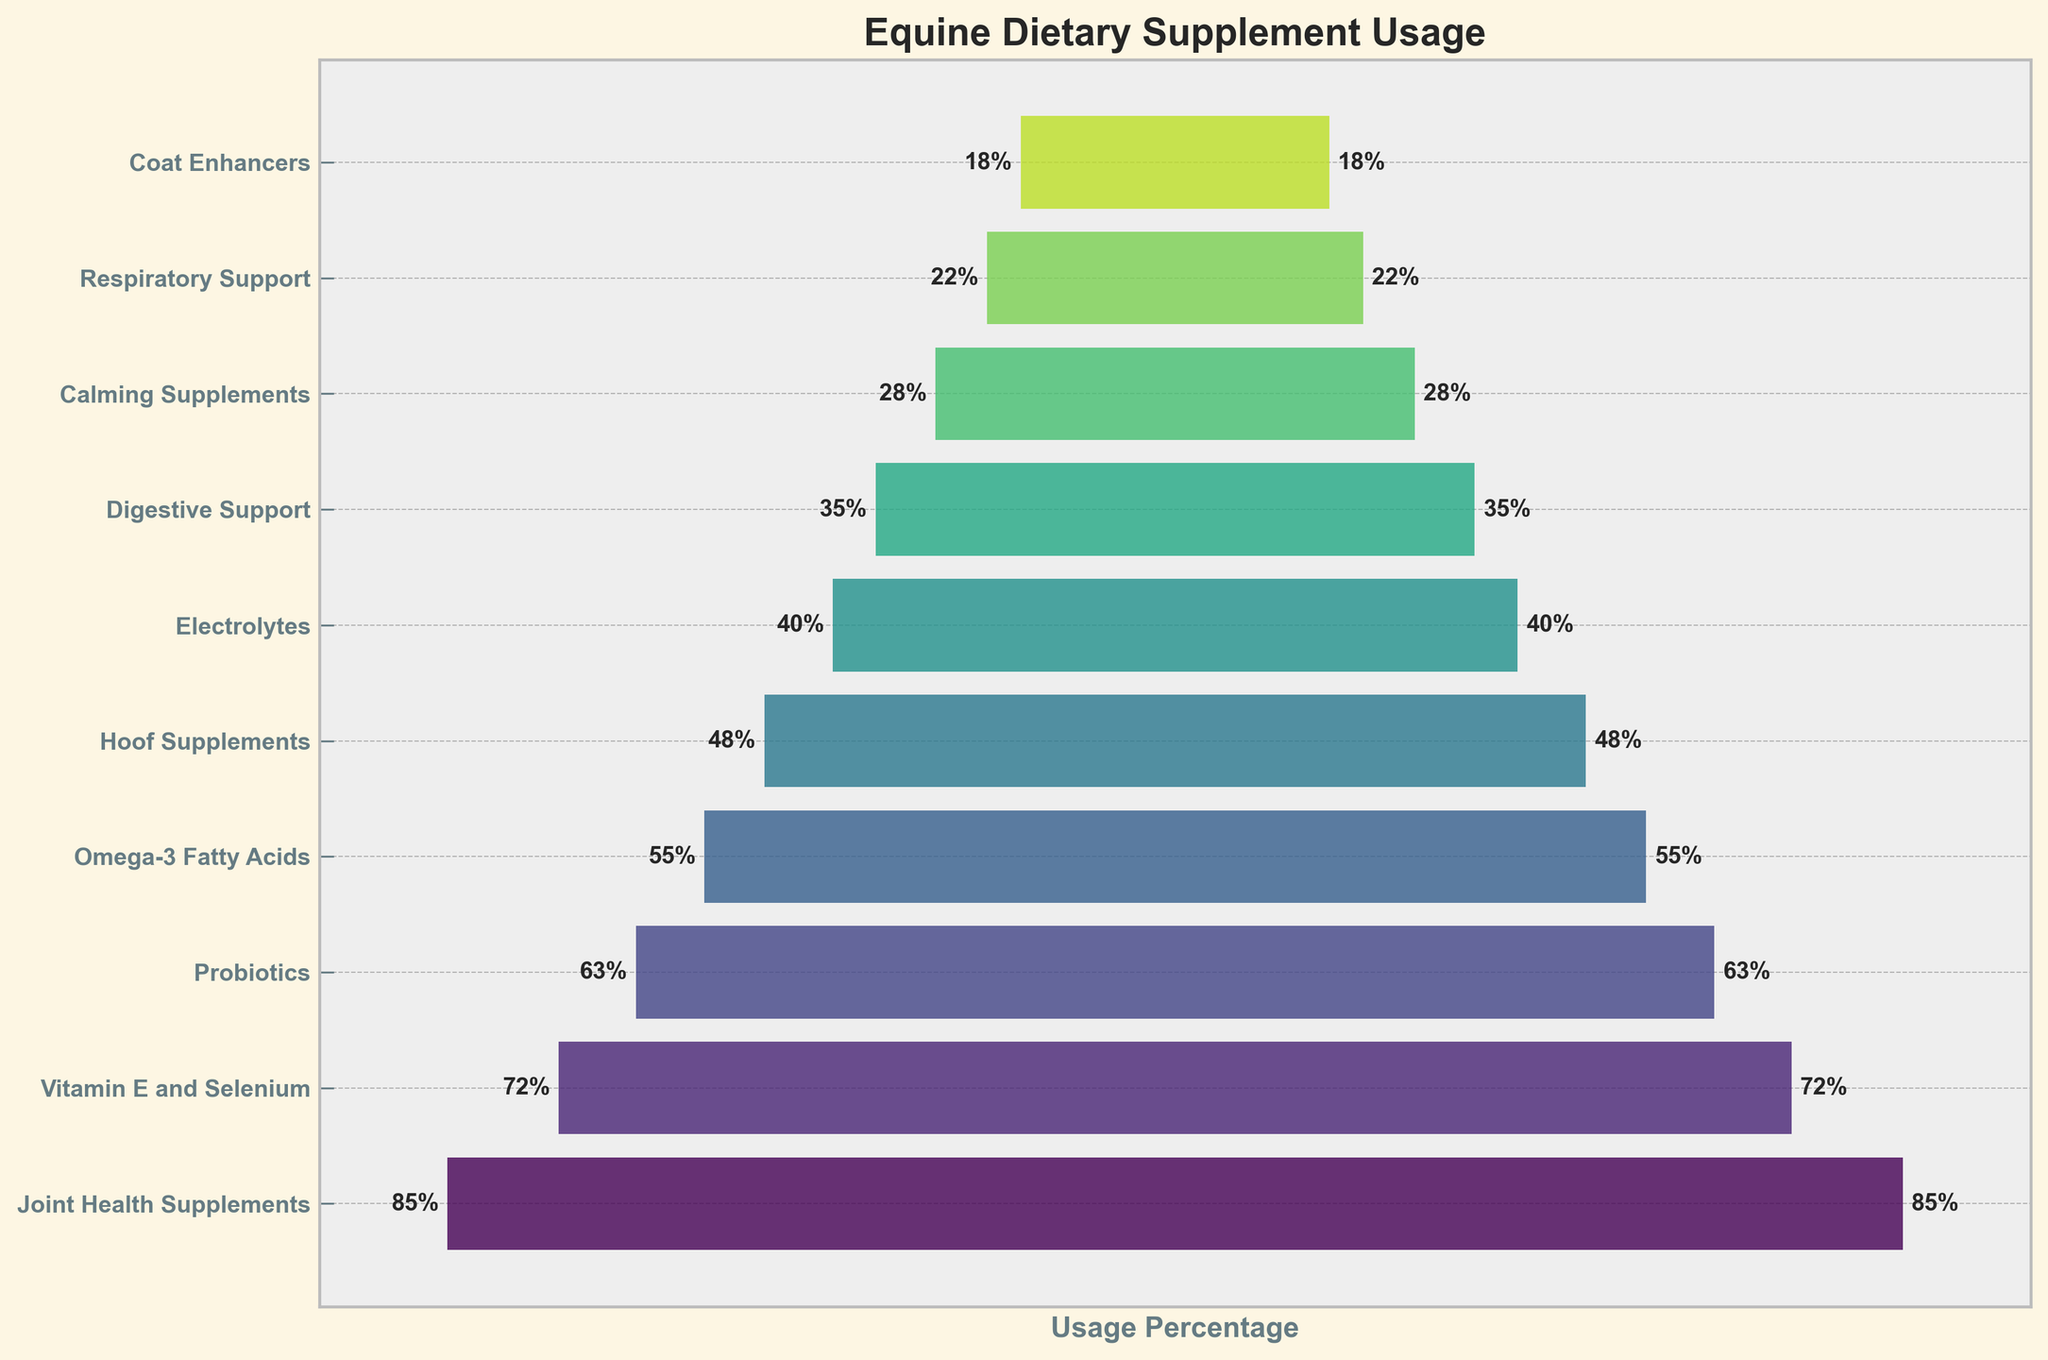What's the most frequently used equine dietary supplement? The top bar in the funnel represents the supplement used by the highest percentage of horses.
Answer: Joint Health Supplements What's the usage percentage of Omega-3 Fatty Acids? Look for the bar labeled Omega-3 Fatty Acids and check the percentage label next to it.
Answer: 55% How many supplements have a usage percentage of 60% or higher? Identify and count the supplements with percentages 60% and above. These are the first three supplements in the funnel chart.
Answer: 3 What's the difference in usage percentage between Joint Health Supplements and Coat Enhancers? Subtract the usage percentage of Coat Enhancers from that of Joint Health Supplements (85% - 18%).
Answer: 67% Which supplement has a lower usage percentage: Probiotics or Hoof Supplements? Compare the usage percentages of Probiotics and Hoof Supplements and determine which is lower.
Answer: Hoof Supplements What's the average usage percentage of the top three most-used supplements? Add the usage percentages of the top three supplements (Joint Health Supplements, Vitamin E and Selenium, Probiotics) and divide by 3 [(85 + 72 + 63) / 3].
Answer: 73.33% If we combine the usage percentages of Digestive Support and Calming Supplements, what would the total be? Add the usage percentages of Digestive Support and Calming Supplements (35% + 28%).
Answer: 63% Do more supplements have a usage percentage above or below 50%? Count the number of supplements with usage percentages above 50% and those below; then compare the two counts.
Answer: Below What's the median usage percentage of all the supplements listed? Arrange the percentages in order and find the middle value (or average of the two middle values if there's an even number). With 10 values, average the 5th and 6th values ((48+40)/2).
Answer: 44% Which supplement shows the least usage percentage? Identify the supplement associated with the smallest bar at the bottom of the funnel chart.
Answer: Coat Enhancers 